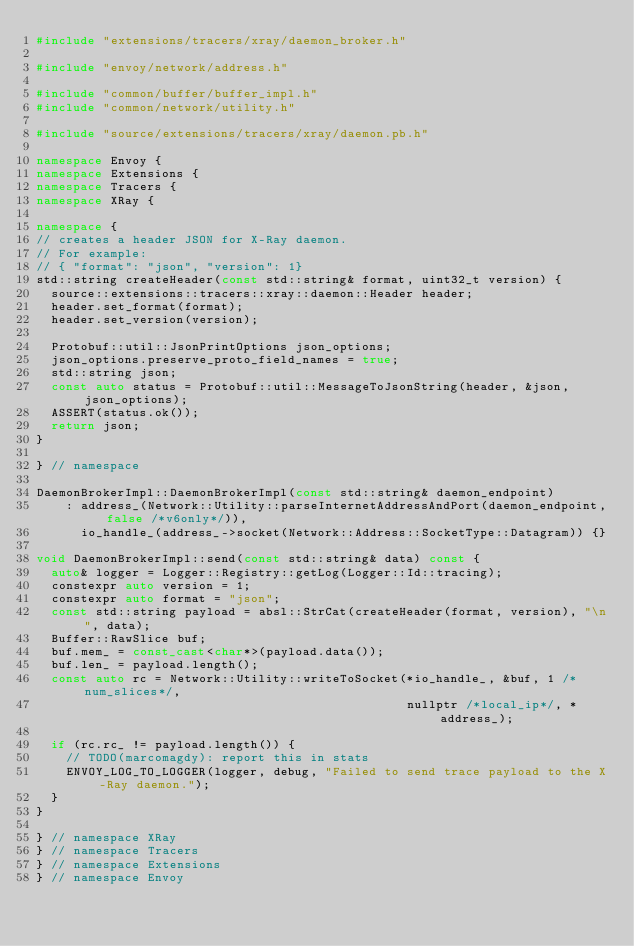Convert code to text. <code><loc_0><loc_0><loc_500><loc_500><_C++_>#include "extensions/tracers/xray/daemon_broker.h"

#include "envoy/network/address.h"

#include "common/buffer/buffer_impl.h"
#include "common/network/utility.h"

#include "source/extensions/tracers/xray/daemon.pb.h"

namespace Envoy {
namespace Extensions {
namespace Tracers {
namespace XRay {

namespace {
// creates a header JSON for X-Ray daemon.
// For example:
// { "format": "json", "version": 1}
std::string createHeader(const std::string& format, uint32_t version) {
  source::extensions::tracers::xray::daemon::Header header;
  header.set_format(format);
  header.set_version(version);

  Protobuf::util::JsonPrintOptions json_options;
  json_options.preserve_proto_field_names = true;
  std::string json;
  const auto status = Protobuf::util::MessageToJsonString(header, &json, json_options);
  ASSERT(status.ok());
  return json;
}

} // namespace

DaemonBrokerImpl::DaemonBrokerImpl(const std::string& daemon_endpoint)
    : address_(Network::Utility::parseInternetAddressAndPort(daemon_endpoint, false /*v6only*/)),
      io_handle_(address_->socket(Network::Address::SocketType::Datagram)) {}

void DaemonBrokerImpl::send(const std::string& data) const {
  auto& logger = Logger::Registry::getLog(Logger::Id::tracing);
  constexpr auto version = 1;
  constexpr auto format = "json";
  const std::string payload = absl::StrCat(createHeader(format, version), "\n", data);
  Buffer::RawSlice buf;
  buf.mem_ = const_cast<char*>(payload.data());
  buf.len_ = payload.length();
  const auto rc = Network::Utility::writeToSocket(*io_handle_, &buf, 1 /*num_slices*/,
                                                  nullptr /*local_ip*/, *address_);

  if (rc.rc_ != payload.length()) {
    // TODO(marcomagdy): report this in stats
    ENVOY_LOG_TO_LOGGER(logger, debug, "Failed to send trace payload to the X-Ray daemon.");
  }
}

} // namespace XRay
} // namespace Tracers
} // namespace Extensions
} // namespace Envoy
</code> 